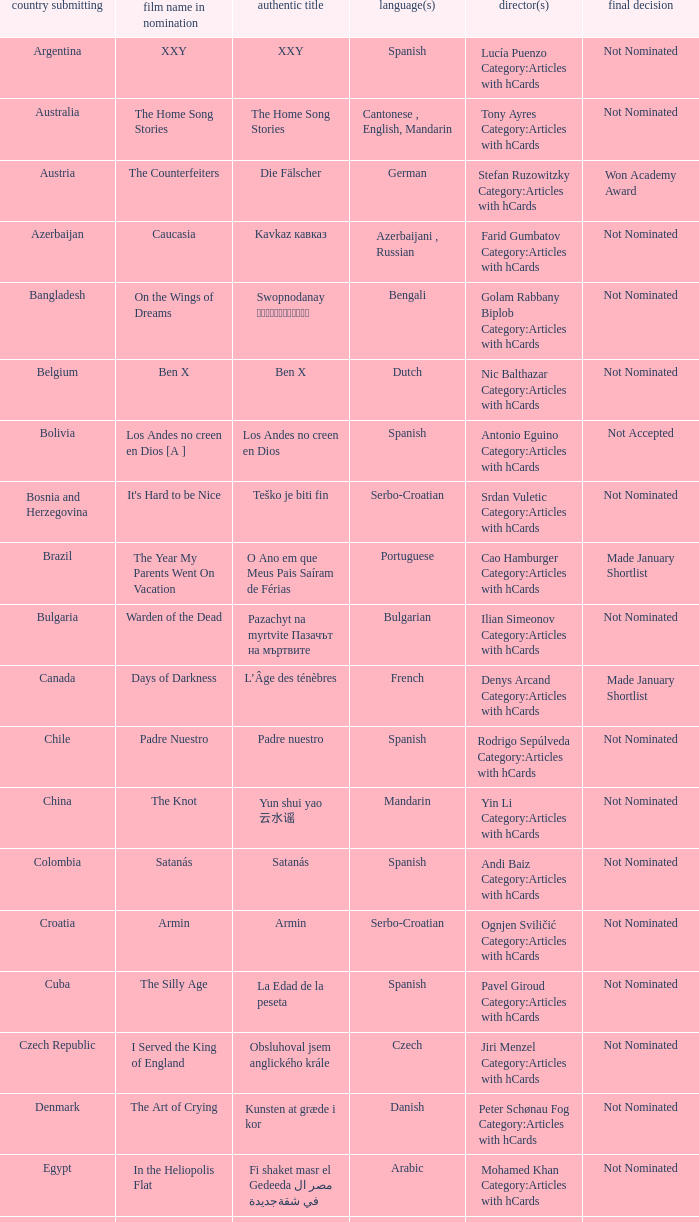What country submitted the movie the orphanage? Spain. 